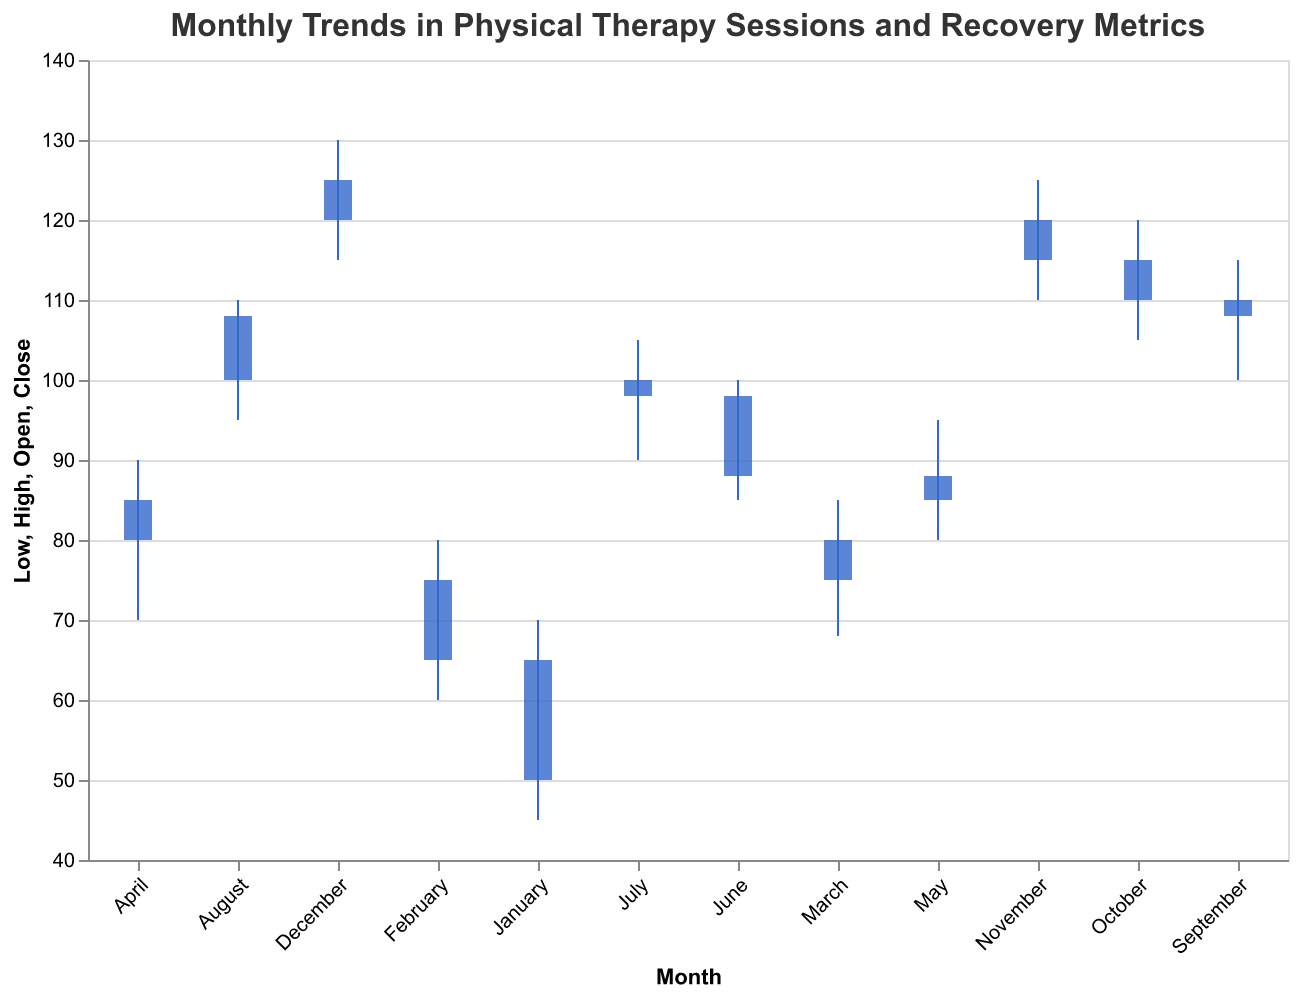What is the title of the figure? The title of the figure is displayed at the top center in a larger font size and reads "Monthly Trends in Physical Therapy Sessions and Recovery Metrics".
Answer: Monthly Trends in Physical Therapy Sessions and Recovery Metrics How many data points are there in the plot? The plot contains one data point for each month of the year from January to December, making it twelve data points in total.
Answer: 12 Which month had the highest closing value? By looking at the height of the bars corresponding to the "Close" values, December has the highest closing value at 125.
Answer: December Which month experienced the largest range between the high and the low values? The largest range is the difference between the "High" and "Low" values. December has a high of 130 and a low of 115, thus a range of 15.
Answer: December What's the average "Open" value for the first quarter (January to March)? Add the "Open" values of January (50), February (65), and March (75). The total is 50 + 65 + 75 = 190. Divide by 3 to get the average, which is 190 / 3 = 63.33.
Answer: 63.33 Did October or November have a higher closing value? By comparing the closing values, November’s closing value (120) is higher than October’s closing value (115).
Answer: November What was the low value in July? The lower edge of the complete vertical line for July represents the low value, which is 90.
Answer: 90 Which month saw the highest high point in the year? By identifying the highest point on the plot, December has the highest high value of 130.
Answer: December Which month had an equal opening and closing value? By matching the bars where the start (open) and end (close) points are the same, July had equal values of 98 (open) and 100 (close).
Answer: July Calculate the increase in the closing value from January to February. The closing value in January is 65 and in February it is 75. The increase is 75 - 65 = 10.
Answer: 10 